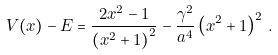Convert formula to latex. <formula><loc_0><loc_0><loc_500><loc_500>V ( x ) - E = \frac { 2 x ^ { 2 } - 1 } { \left ( x ^ { 2 } + 1 \right ) ^ { 2 } } - \frac { \gamma ^ { 2 } } { a ^ { 4 } } \left ( x ^ { 2 } + 1 \right ) ^ { 2 } \, .</formula> 